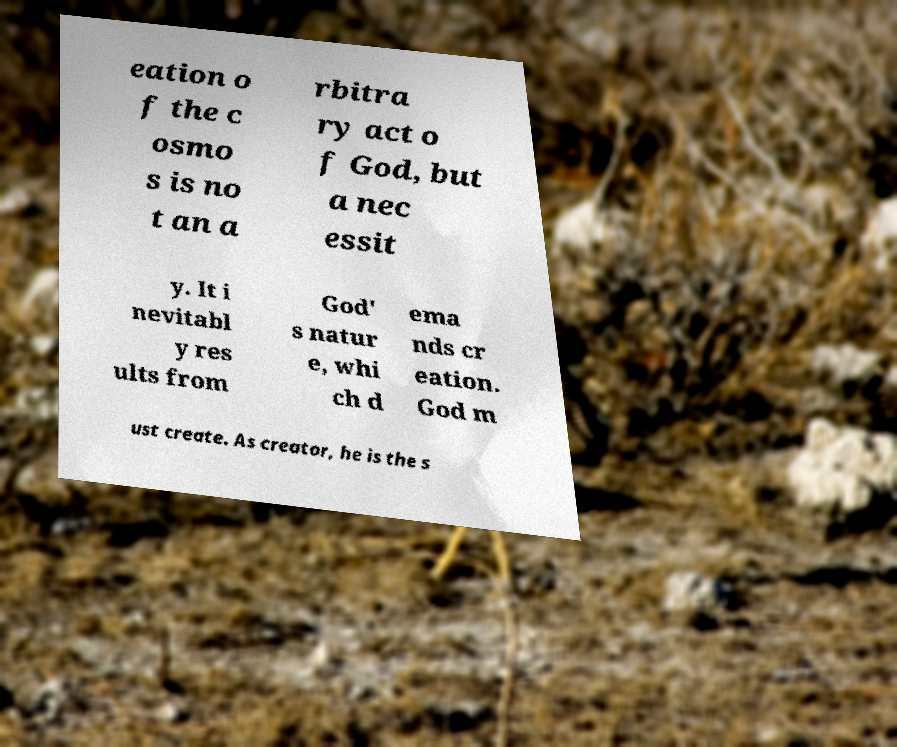Please read and relay the text visible in this image. What does it say? eation o f the c osmo s is no t an a rbitra ry act o f God, but a nec essit y. It i nevitabl y res ults from God' s natur e, whi ch d ema nds cr eation. God m ust create. As creator, he is the s 